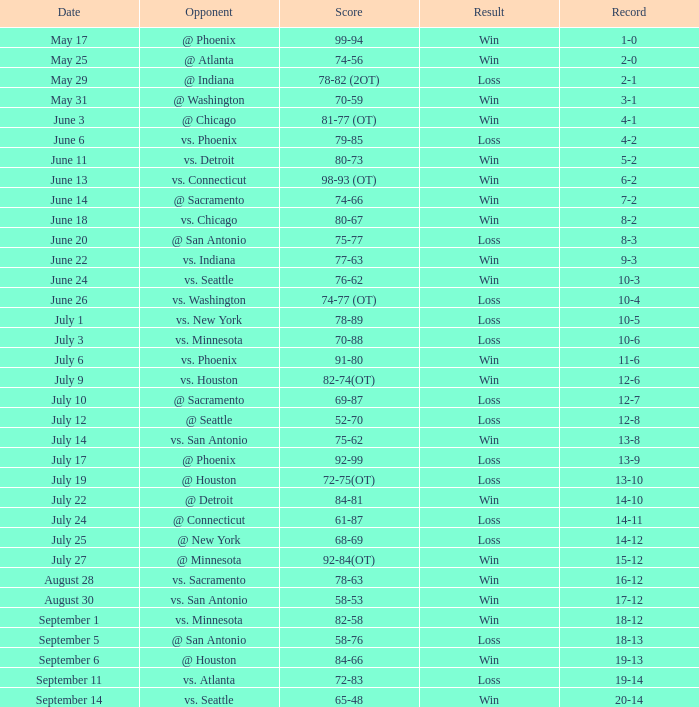What is the Record of the game with a Score of 65-48? 20-14. 